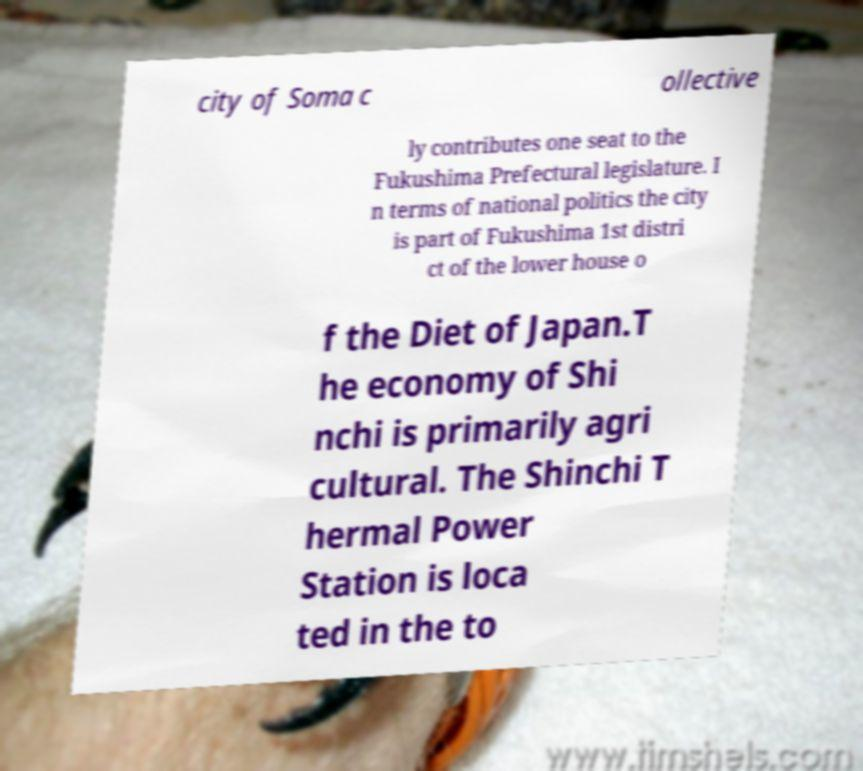Can you read and provide the text displayed in the image?This photo seems to have some interesting text. Can you extract and type it out for me? city of Soma c ollective ly contributes one seat to the Fukushima Prefectural legislature. I n terms of national politics the city is part of Fukushima 1st distri ct of the lower house o f the Diet of Japan.T he economy of Shi nchi is primarily agri cultural. The Shinchi T hermal Power Station is loca ted in the to 